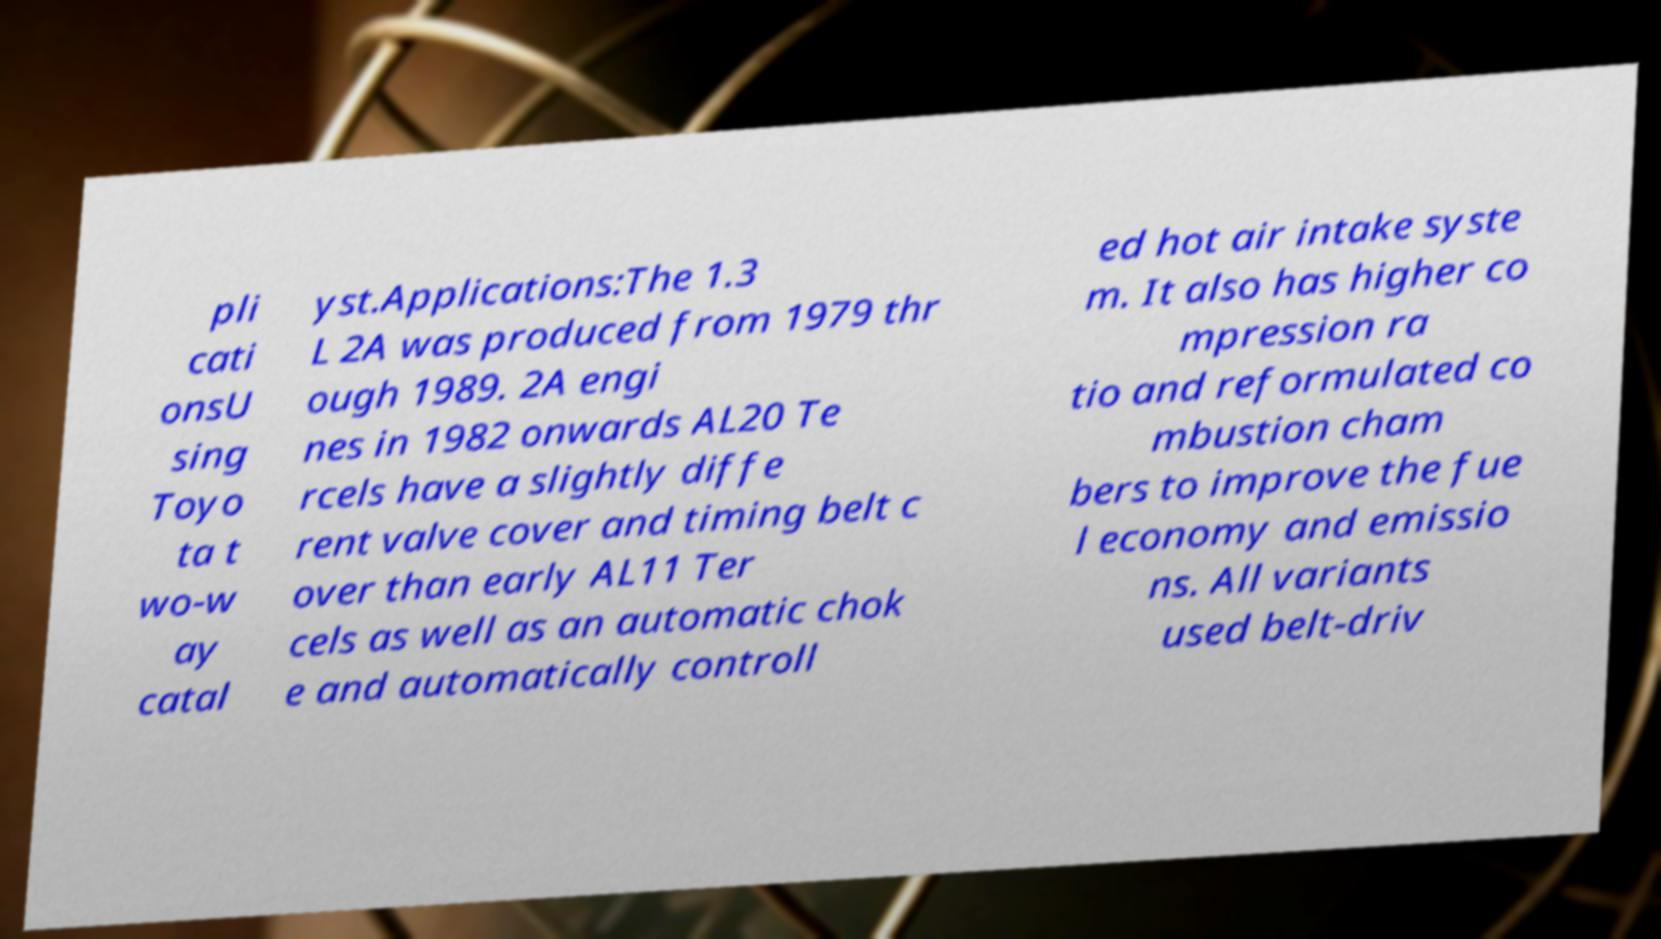I need the written content from this picture converted into text. Can you do that? pli cati onsU sing Toyo ta t wo-w ay catal yst.Applications:The 1.3 L 2A was produced from 1979 thr ough 1989. 2A engi nes in 1982 onwards AL20 Te rcels have a slightly diffe rent valve cover and timing belt c over than early AL11 Ter cels as well as an automatic chok e and automatically controll ed hot air intake syste m. It also has higher co mpression ra tio and reformulated co mbustion cham bers to improve the fue l economy and emissio ns. All variants used belt-driv 